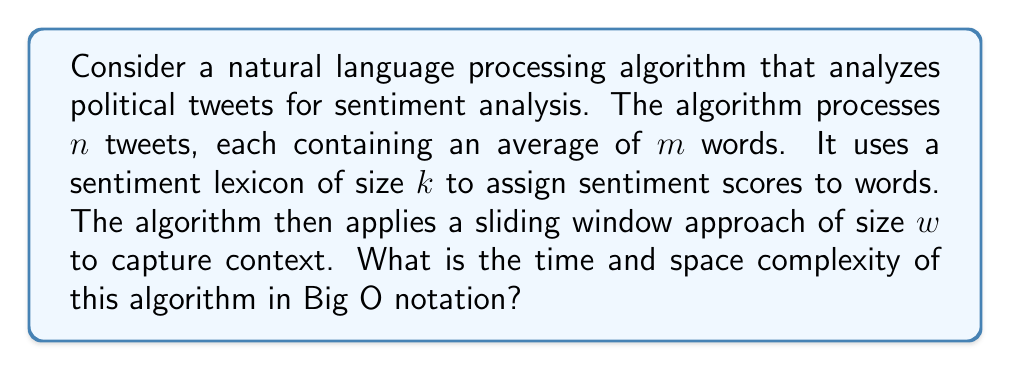Can you answer this question? Let's break down the algorithm and analyze its complexity step by step:

1. Processing tweets:
   - The algorithm processes $n$ tweets, each with an average of $m$ words.
   - Time complexity for this step: $O(n \cdot m)$

2. Sentiment lexicon lookup:
   - For each word in each tweet, the algorithm performs a lookup in the sentiment lexicon of size $k$.
   - Assuming the lexicon is implemented as a hash table with O(1) lookup time:
   - Time complexity for this step: $O(n \cdot m)$

3. Sliding window approach:
   - For each tweet, the algorithm applies a sliding window of size $w$.
   - This results in $(m - w + 1)$ windows per tweet.
   - For each window, we perform some constant-time operations.
   - Time complexity for this step: $O(n \cdot (m - w + 1)) \approx O(n \cdot m)$ (since $w$ is typically much smaller than $m$)

4. Space complexity:
   - The algorithm needs to store:
     a) The input tweets: $O(n \cdot m)$
     b) The sentiment lexicon: $O(k)$
     c) Temporary storage for sliding windows: $O(w)$

Combining these steps:

Time complexity: $O(n \cdot m)$ + $O(n \cdot m)$ + $O(n \cdot m)$ = $O(n \cdot m)$

Space complexity: $O(n \cdot m + k + w)$

Since $k$ (lexicon size) and $w$ (window size) are typically much smaller than $n \cdot m$ (total number of words in all tweets), we can simplify the space complexity to $O(n \cdot m)$.
Answer: Time complexity: $O(n \cdot m)$
Space complexity: $O(n \cdot m)$

Where $n$ is the number of tweets and $m$ is the average number of words per tweet. 